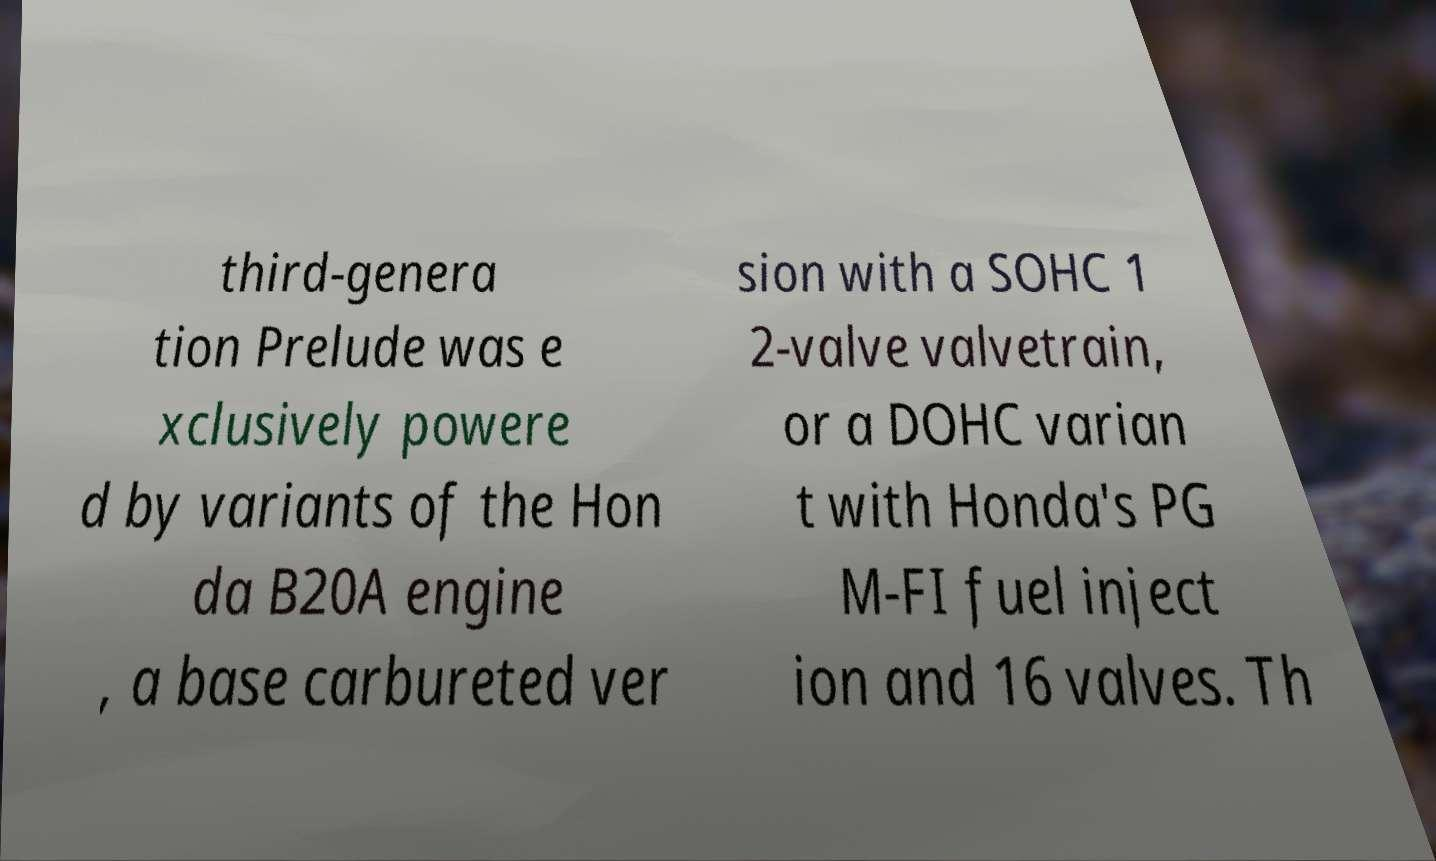Can you read and provide the text displayed in the image?This photo seems to have some interesting text. Can you extract and type it out for me? third-genera tion Prelude was e xclusively powere d by variants of the Hon da B20A engine , a base carbureted ver sion with a SOHC 1 2-valve valvetrain, or a DOHC varian t with Honda's PG M-FI fuel inject ion and 16 valves. Th 